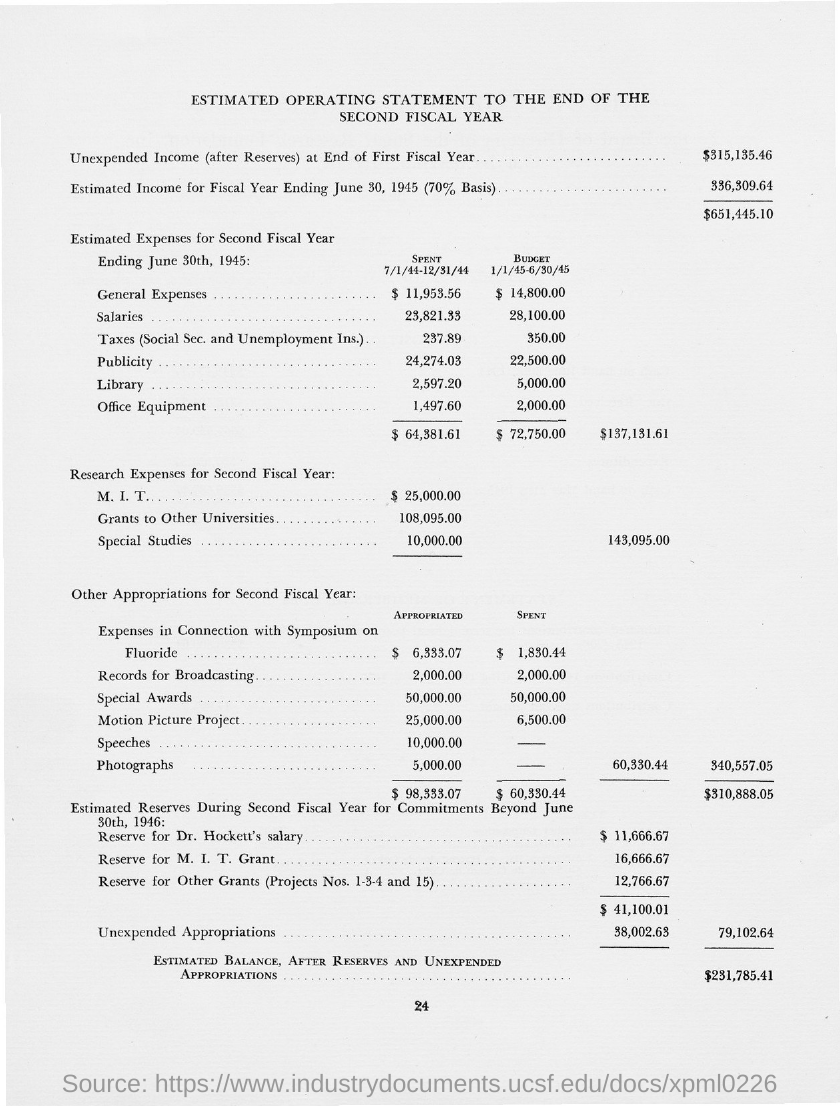What is unexpended income (after reserves ) at end of first fiscal year ?
Ensure brevity in your answer.  $315,135.46. What is the estimated income for fiscal year ending june 30,1945(70% basis)?
Keep it short and to the point. 336,309.64. What is the page number at bottom of the page?
Offer a very short reply. 24. 